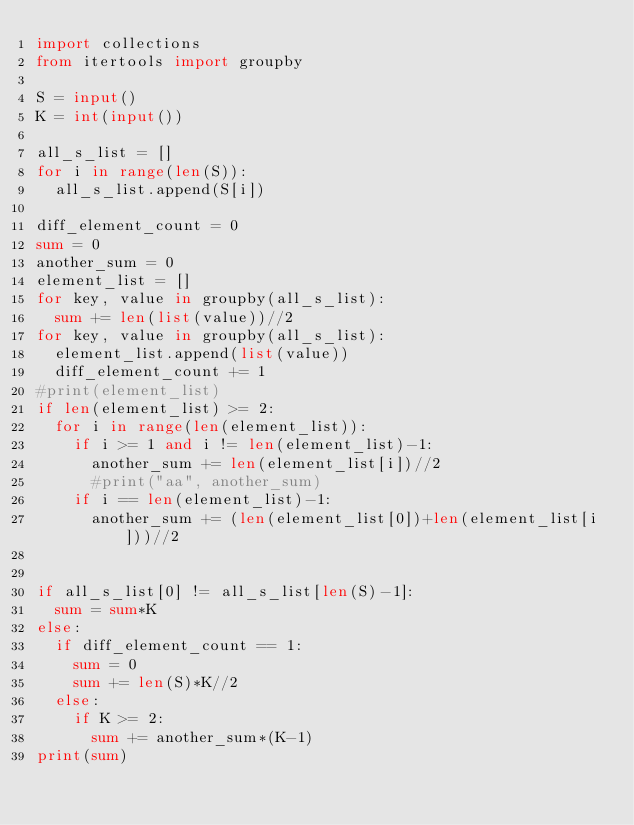Convert code to text. <code><loc_0><loc_0><loc_500><loc_500><_Python_>import collections
from itertools import groupby

S = input()
K = int(input())

all_s_list = []
for i in range(len(S)):
  all_s_list.append(S[i])

diff_element_count = 0
sum = 0
another_sum = 0
element_list = []
for key, value in groupby(all_s_list):
  sum += len(list(value))//2
for key, value in groupby(all_s_list):
  element_list.append(list(value))
  diff_element_count += 1
#print(element_list)
if len(element_list) >= 2:
  for i in range(len(element_list)):
    if i >= 1 and i != len(element_list)-1:
      another_sum += len(element_list[i])//2
      #print("aa", another_sum)
    if i == len(element_list)-1:
      another_sum += (len(element_list[0])+len(element_list[i]))//2


if all_s_list[0] != all_s_list[len(S)-1]:    
  sum = sum*K
else:
  if diff_element_count == 1:
    sum = 0
    sum += len(S)*K//2
  else:
    if K >= 2:
      sum += another_sum*(K-1)
print(sum)</code> 